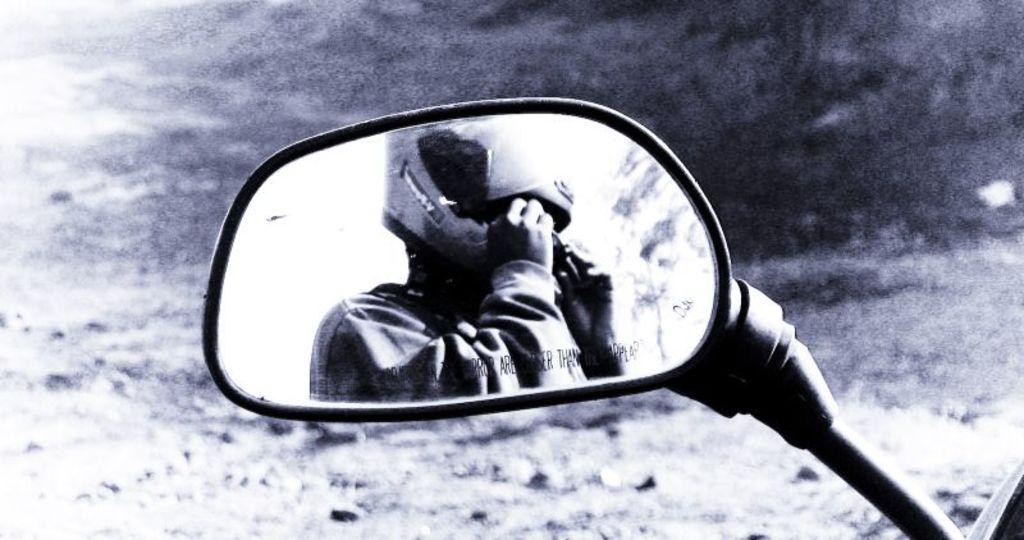What object is the main focus of the image? The main object in the image is a vehicle side mirror. What can be seen in the side mirror? The side mirror reflects a man wearing a helmet. What type of lunch is the man eating in the image? There is no indication of the man eating lunch in the image, as he is only wearing a helmet and not engaging in any eating activity. 